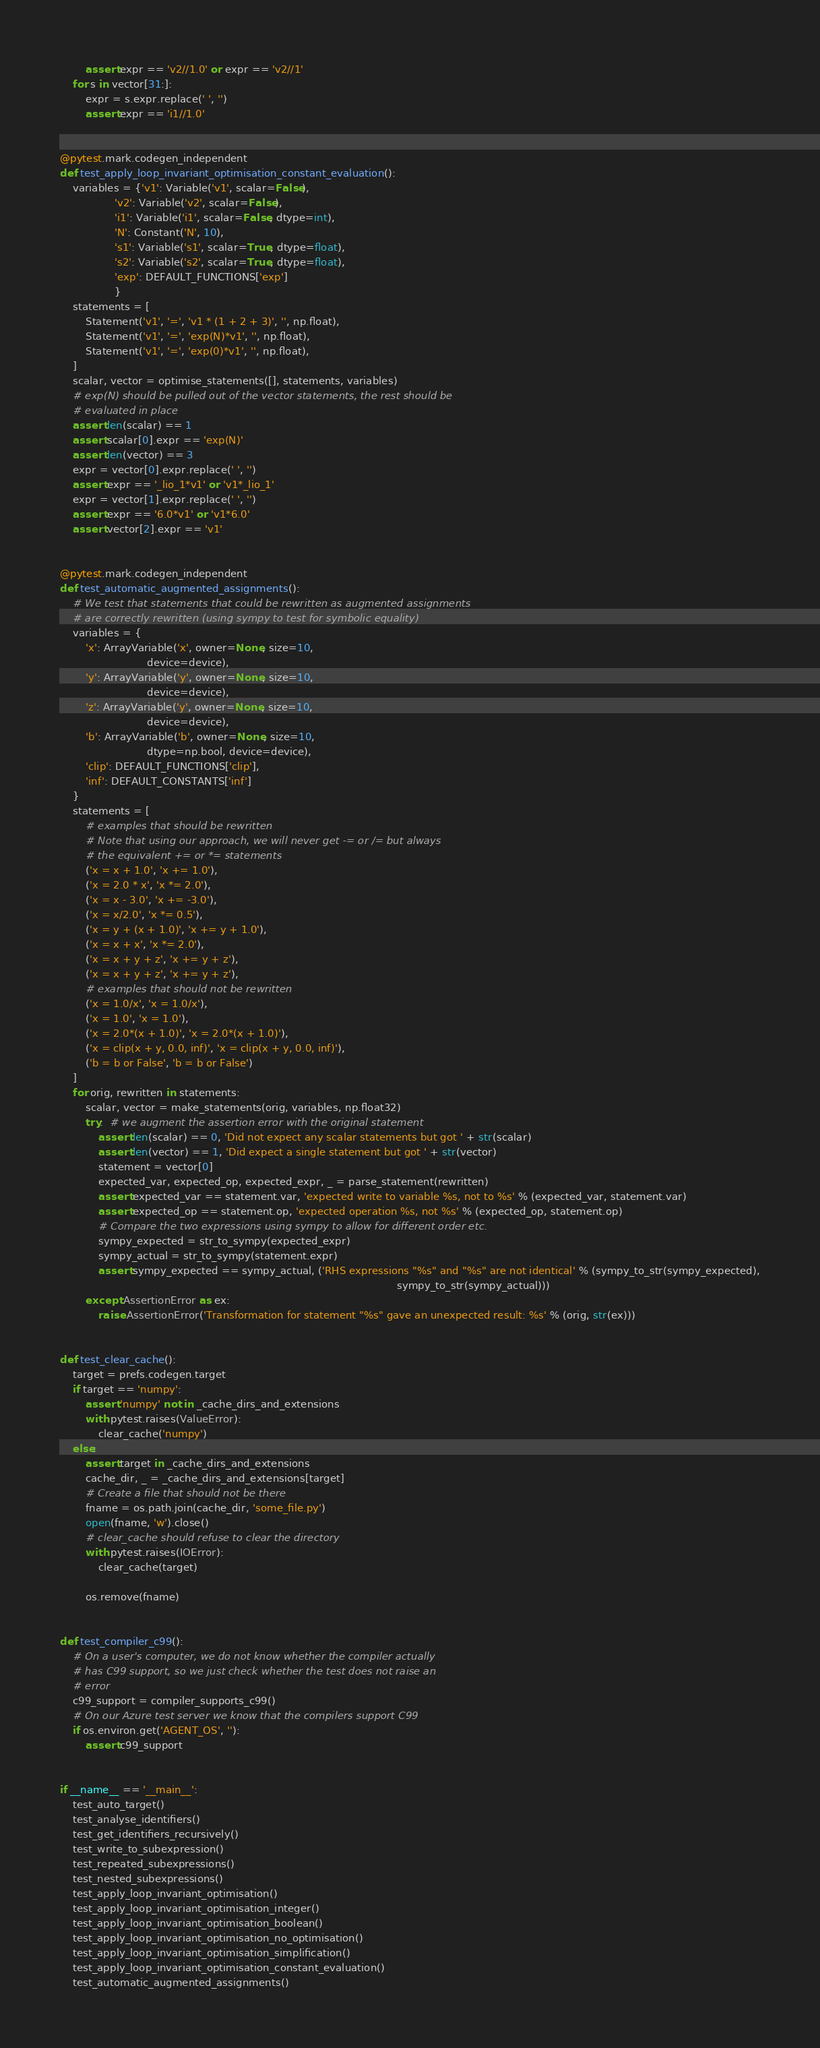<code> <loc_0><loc_0><loc_500><loc_500><_Python_>        assert expr == 'v2//1.0' or expr == 'v2//1'
    for s in vector[31:]:
        expr = s.expr.replace(' ', '')
        assert expr == 'i1//1.0'


@pytest.mark.codegen_independent
def test_apply_loop_invariant_optimisation_constant_evaluation():
    variables = {'v1': Variable('v1', scalar=False),
                 'v2': Variable('v2', scalar=False),
                 'i1': Variable('i1', scalar=False, dtype=int),
                 'N': Constant('N', 10),
                 's1': Variable('s1', scalar=True, dtype=float),
                 's2': Variable('s2', scalar=True, dtype=float),
                 'exp': DEFAULT_FUNCTIONS['exp']
                 }
    statements = [
        Statement('v1', '=', 'v1 * (1 + 2 + 3)', '', np.float),
        Statement('v1', '=', 'exp(N)*v1', '', np.float),
        Statement('v1', '=', 'exp(0)*v1', '', np.float),
    ]
    scalar, vector = optimise_statements([], statements, variables)
    # exp(N) should be pulled out of the vector statements, the rest should be
    # evaluated in place
    assert len(scalar) == 1
    assert scalar[0].expr == 'exp(N)'
    assert len(vector) == 3
    expr = vector[0].expr.replace(' ', '')
    assert expr == '_lio_1*v1' or 'v1*_lio_1'
    expr = vector[1].expr.replace(' ', '')
    assert expr == '6.0*v1' or 'v1*6.0'
    assert vector[2].expr == 'v1'


@pytest.mark.codegen_independent
def test_automatic_augmented_assignments():
    # We test that statements that could be rewritten as augmented assignments
    # are correctly rewritten (using sympy to test for symbolic equality)
    variables = {
        'x': ArrayVariable('x', owner=None, size=10,
                           device=device),
        'y': ArrayVariable('y', owner=None, size=10,
                           device=device),
        'z': ArrayVariable('y', owner=None, size=10,
                           device=device),
        'b': ArrayVariable('b', owner=None, size=10,
                           dtype=np.bool, device=device),
        'clip': DEFAULT_FUNCTIONS['clip'],
        'inf': DEFAULT_CONSTANTS['inf']
    }
    statements = [
        # examples that should be rewritten
        # Note that using our approach, we will never get -= or /= but always
        # the equivalent += or *= statements
        ('x = x + 1.0', 'x += 1.0'),
        ('x = 2.0 * x', 'x *= 2.0'),
        ('x = x - 3.0', 'x += -3.0'),
        ('x = x/2.0', 'x *= 0.5'),
        ('x = y + (x + 1.0)', 'x += y + 1.0'),
        ('x = x + x', 'x *= 2.0'),
        ('x = x + y + z', 'x += y + z'),
        ('x = x + y + z', 'x += y + z'),
        # examples that should not be rewritten
        ('x = 1.0/x', 'x = 1.0/x'),
        ('x = 1.0', 'x = 1.0'),
        ('x = 2.0*(x + 1.0)', 'x = 2.0*(x + 1.0)'),
        ('x = clip(x + y, 0.0, inf)', 'x = clip(x + y, 0.0, inf)'),
        ('b = b or False', 'b = b or False')
    ]
    for orig, rewritten in statements:
        scalar, vector = make_statements(orig, variables, np.float32)
        try:  # we augment the assertion error with the original statement
            assert len(scalar) == 0, 'Did not expect any scalar statements but got ' + str(scalar)
            assert len(vector) == 1, 'Did expect a single statement but got ' + str(vector)
            statement = vector[0]
            expected_var, expected_op, expected_expr, _ = parse_statement(rewritten)
            assert expected_var == statement.var, 'expected write to variable %s, not to %s' % (expected_var, statement.var)
            assert expected_op == statement.op, 'expected operation %s, not %s' % (expected_op, statement.op)
            # Compare the two expressions using sympy to allow for different order etc.
            sympy_expected = str_to_sympy(expected_expr)
            sympy_actual = str_to_sympy(statement.expr)
            assert sympy_expected == sympy_actual, ('RHS expressions "%s" and "%s" are not identical' % (sympy_to_str(sympy_expected),
                                                                                                         sympy_to_str(sympy_actual)))
        except AssertionError as ex:
            raise AssertionError('Transformation for statement "%s" gave an unexpected result: %s' % (orig, str(ex)))


def test_clear_cache():
    target = prefs.codegen.target
    if target == 'numpy':
        assert 'numpy' not in _cache_dirs_and_extensions
        with pytest.raises(ValueError):
            clear_cache('numpy')
    else:
        assert target in _cache_dirs_and_extensions
        cache_dir, _ = _cache_dirs_and_extensions[target]
        # Create a file that should not be there
        fname = os.path.join(cache_dir, 'some_file.py')
        open(fname, 'w').close()
        # clear_cache should refuse to clear the directory
        with pytest.raises(IOError):
            clear_cache(target)

        os.remove(fname)


def test_compiler_c99():
    # On a user's computer, we do not know whether the compiler actually
    # has C99 support, so we just check whether the test does not raise an
    # error
    c99_support = compiler_supports_c99()
    # On our Azure test server we know that the compilers support C99
    if os.environ.get('AGENT_OS', ''):
        assert c99_support


if __name__ == '__main__':
    test_auto_target()
    test_analyse_identifiers()
    test_get_identifiers_recursively()
    test_write_to_subexpression()
    test_repeated_subexpressions()
    test_nested_subexpressions()
    test_apply_loop_invariant_optimisation()
    test_apply_loop_invariant_optimisation_integer()
    test_apply_loop_invariant_optimisation_boolean()
    test_apply_loop_invariant_optimisation_no_optimisation()
    test_apply_loop_invariant_optimisation_simplification()
    test_apply_loop_invariant_optimisation_constant_evaluation()
    test_automatic_augmented_assignments()</code> 